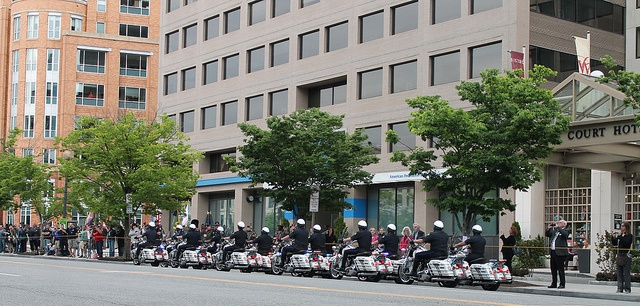Describe the objects in this image and their specific colors. I can see people in tan, black, gray, darkgray, and lightgray tones, motorcycle in tan, black, gray, darkgray, and lightgray tones, motorcycle in tan, black, gray, lightgray, and darkgray tones, motorcycle in tan, black, gray, darkgray, and lightgray tones, and motorcycle in tan, black, gray, darkgray, and lightgray tones in this image. 